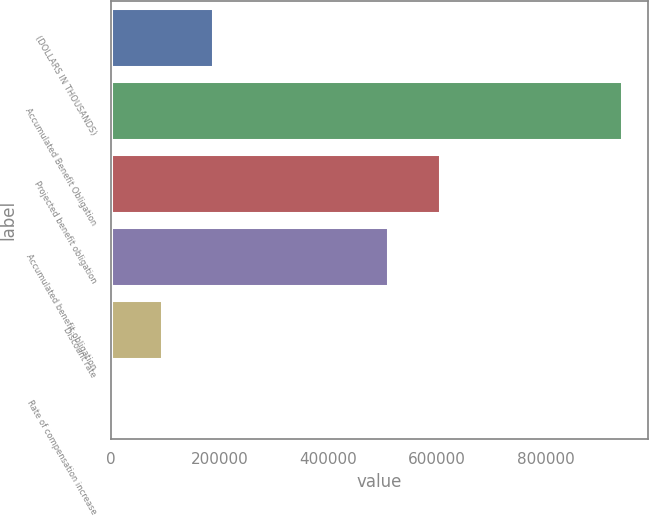Convert chart. <chart><loc_0><loc_0><loc_500><loc_500><bar_chart><fcel>(DOLLARS IN THOUSANDS)<fcel>Accumulated Benefit Obligation<fcel>Projected benefit obligation<fcel>Accumulated benefit obligation<fcel>Discount rate<fcel>Rate of compensation increase<nl><fcel>188233<fcel>941158<fcel>605055<fcel>510939<fcel>94117.6<fcel>1.98<nl></chart> 